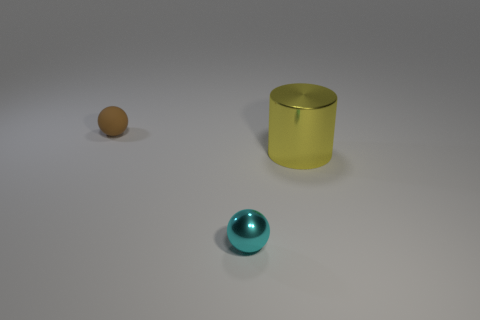Add 3 gray matte cylinders. How many objects exist? 6 Subtract all spheres. How many objects are left? 1 Subtract all small balls. Subtract all brown things. How many objects are left? 0 Add 2 big yellow objects. How many big yellow objects are left? 3 Add 1 balls. How many balls exist? 3 Subtract 0 gray cubes. How many objects are left? 3 